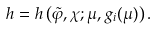<formula> <loc_0><loc_0><loc_500><loc_500>h = h \left ( \tilde { \varphi } , \chi ; \mu , g _ { i } ( \mu ) \right ) .</formula> 